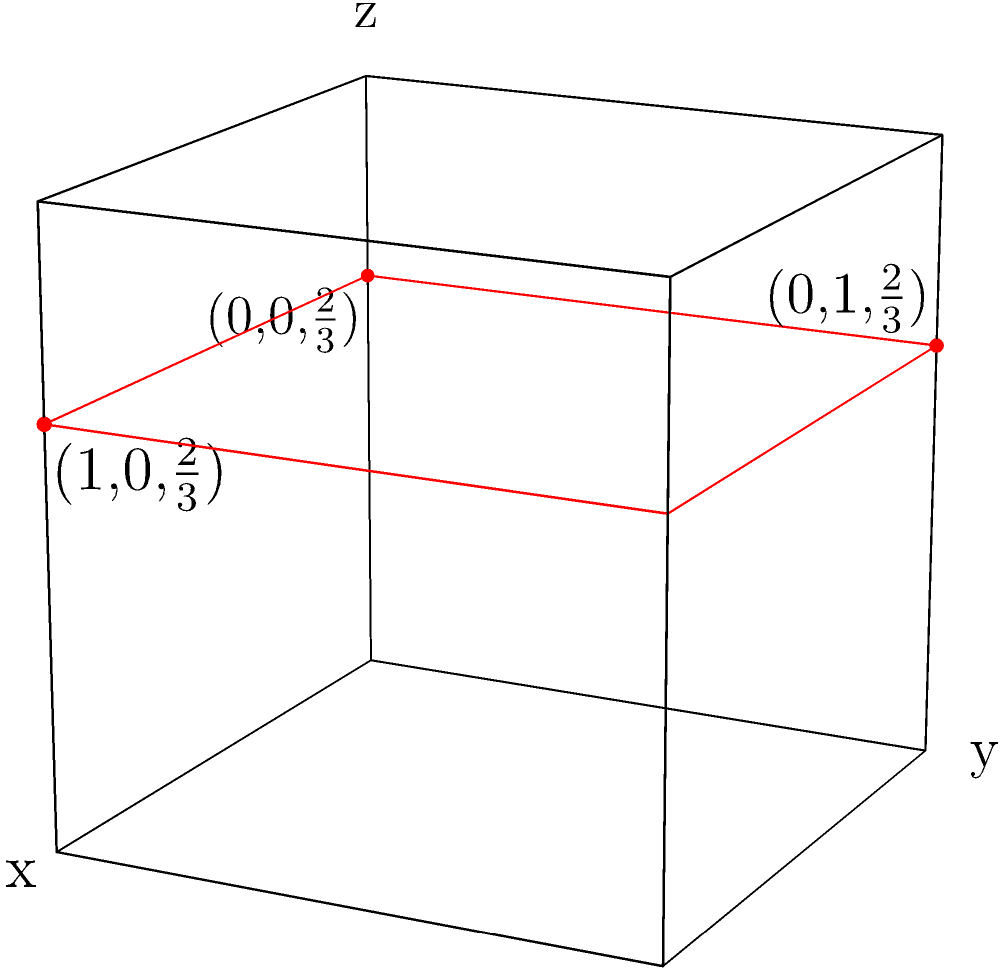In the crystallographic unit cell shown above, a lattice plane (highlighted in red) intersects the x-axis at (1,0,2/3), the y-axis at (0,1,2/3), and the z-axis at (0,0,2/3). Calculate the Miller indices (hkl) for this plane. To calculate the Miller indices (hkl) for the given lattice plane, we need to follow these steps:

1. Determine the intercepts of the plane with the x, y, and z axes:
   x-intercept: 1
   y-intercept: 1
   z-intercept: 2/3

2. Take the reciprocals of these intercepts:
   1/x = 1/1 = 1
   1/y = 1/1 = 1
   1/z = 1/(2/3) = 3/2

3. Reduce these fractions to the smallest set of integers with the same ratio:
   (1 : 1 : 3/2) = (2 : 2 : 3)

4. The Miller indices (hkl) are these reduced reciprocals:
   h = 2, k = 2, l = 3

Therefore, the Miller indices for this plane are (223).

Note: In crystallography, it's conventional to use the smallest set of integers without a common factor to express Miller indices. In this case, (223) cannot be reduced further.
Answer: (223) 